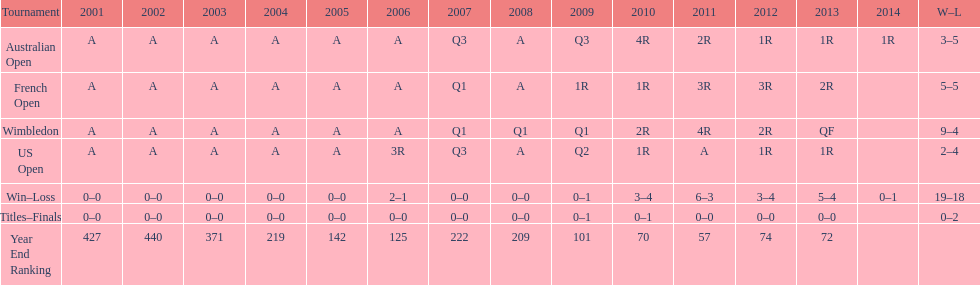How many events had a total of 5 losses? 2. 